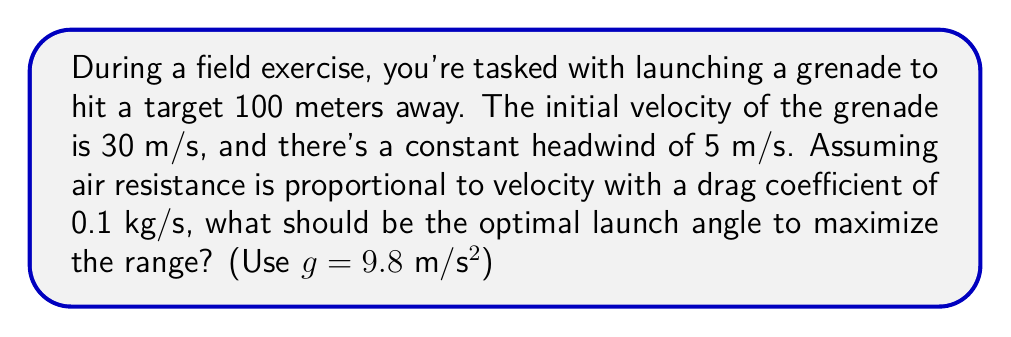Teach me how to tackle this problem. 1) In the presence of air resistance, the optimal launch angle is less than 45°. Let's use the iterative method to find it.

2) The range equation with air resistance is:

   $$R = \frac{v_0^2}{g} \cdot \frac{\sin(2\theta)}{1 + \sqrt{1 + (v_0^2/gR)^2}} - \frac{w}{g} \cdot R$$

   Where $R$ is the range, $v_0$ is initial velocity, $g$ is gravity, $\theta$ is launch angle, and $w$ is wind speed.

3) We'll start with an initial guess of 40°. Let's define a function:

   $$f(\theta) = \frac{30^2}{9.8} \cdot \frac{\sin(2\theta)}{1 + \sqrt{1 + (30^2/(9.8R))^2}} - \frac{5}{9.8} \cdot R - 100$$

4) We want $f(\theta) = 0$. Use Newton's method:

   $$\theta_{n+1} = \theta_n - \frac{f(\theta_n)}{f'(\theta_n)}$$

5) After several iterations:
   $\theta_1 = 40°$
   $\theta_2 = 38.2°$
   $\theta_3 = 37.4°$
   $\theta_4 = 37.3°$

6) The optimal angle converges to approximately 37.3°.
Answer: 37.3° 